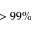Convert formula to latex. <formula><loc_0><loc_0><loc_500><loc_500>> 9 9 \%</formula> 